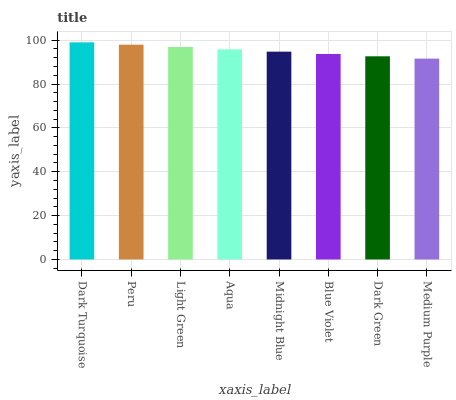Is Medium Purple the minimum?
Answer yes or no. Yes. Is Dark Turquoise the maximum?
Answer yes or no. Yes. Is Peru the minimum?
Answer yes or no. No. Is Peru the maximum?
Answer yes or no. No. Is Dark Turquoise greater than Peru?
Answer yes or no. Yes. Is Peru less than Dark Turquoise?
Answer yes or no. Yes. Is Peru greater than Dark Turquoise?
Answer yes or no. No. Is Dark Turquoise less than Peru?
Answer yes or no. No. Is Aqua the high median?
Answer yes or no. Yes. Is Midnight Blue the low median?
Answer yes or no. Yes. Is Medium Purple the high median?
Answer yes or no. No. Is Light Green the low median?
Answer yes or no. No. 